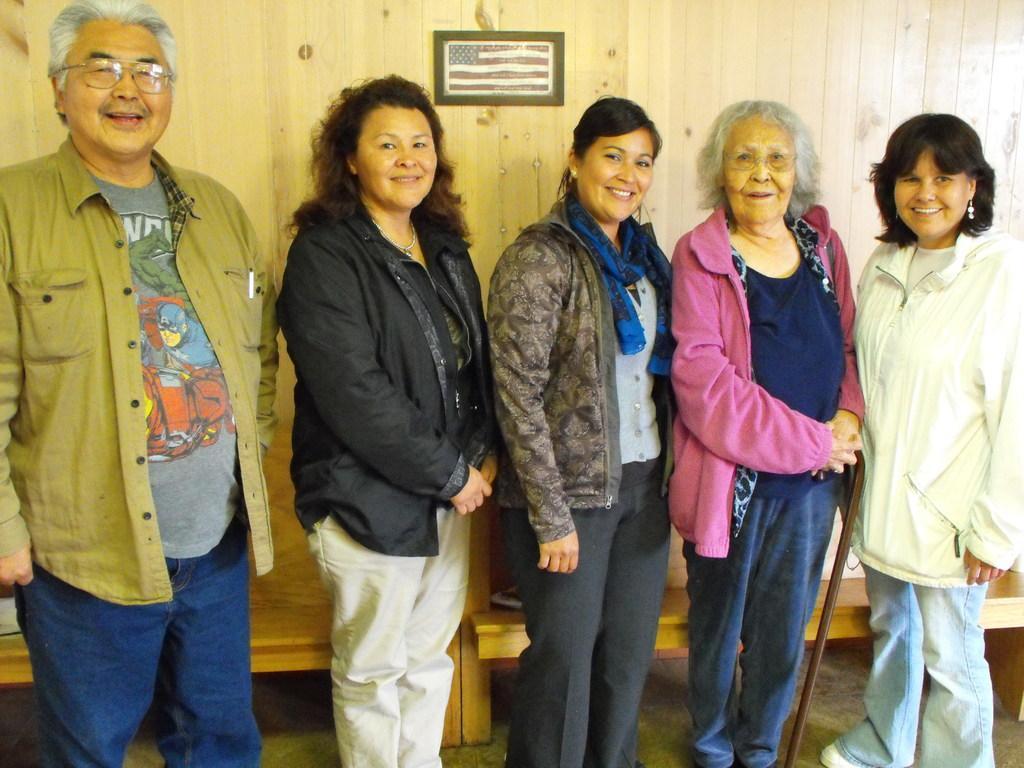Could you give a brief overview of what you see in this image? In the image I can see people are standing and smiling. Some of them are wearing spectacles. In the background I can see a wooden wall which has an object attached to it. The woman in the middle is holding a stick in hands. 